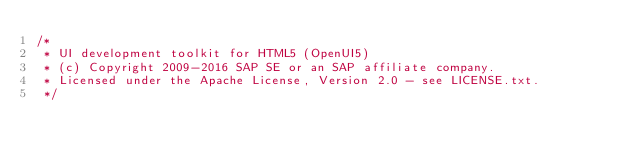<code> <loc_0><loc_0><loc_500><loc_500><_JavaScript_>/*
 * UI development toolkit for HTML5 (OpenUI5)
 * (c) Copyright 2009-2016 SAP SE or an SAP affiliate company.
 * Licensed under the Apache License, Version 2.0 - see LICENSE.txt.
 */</code> 